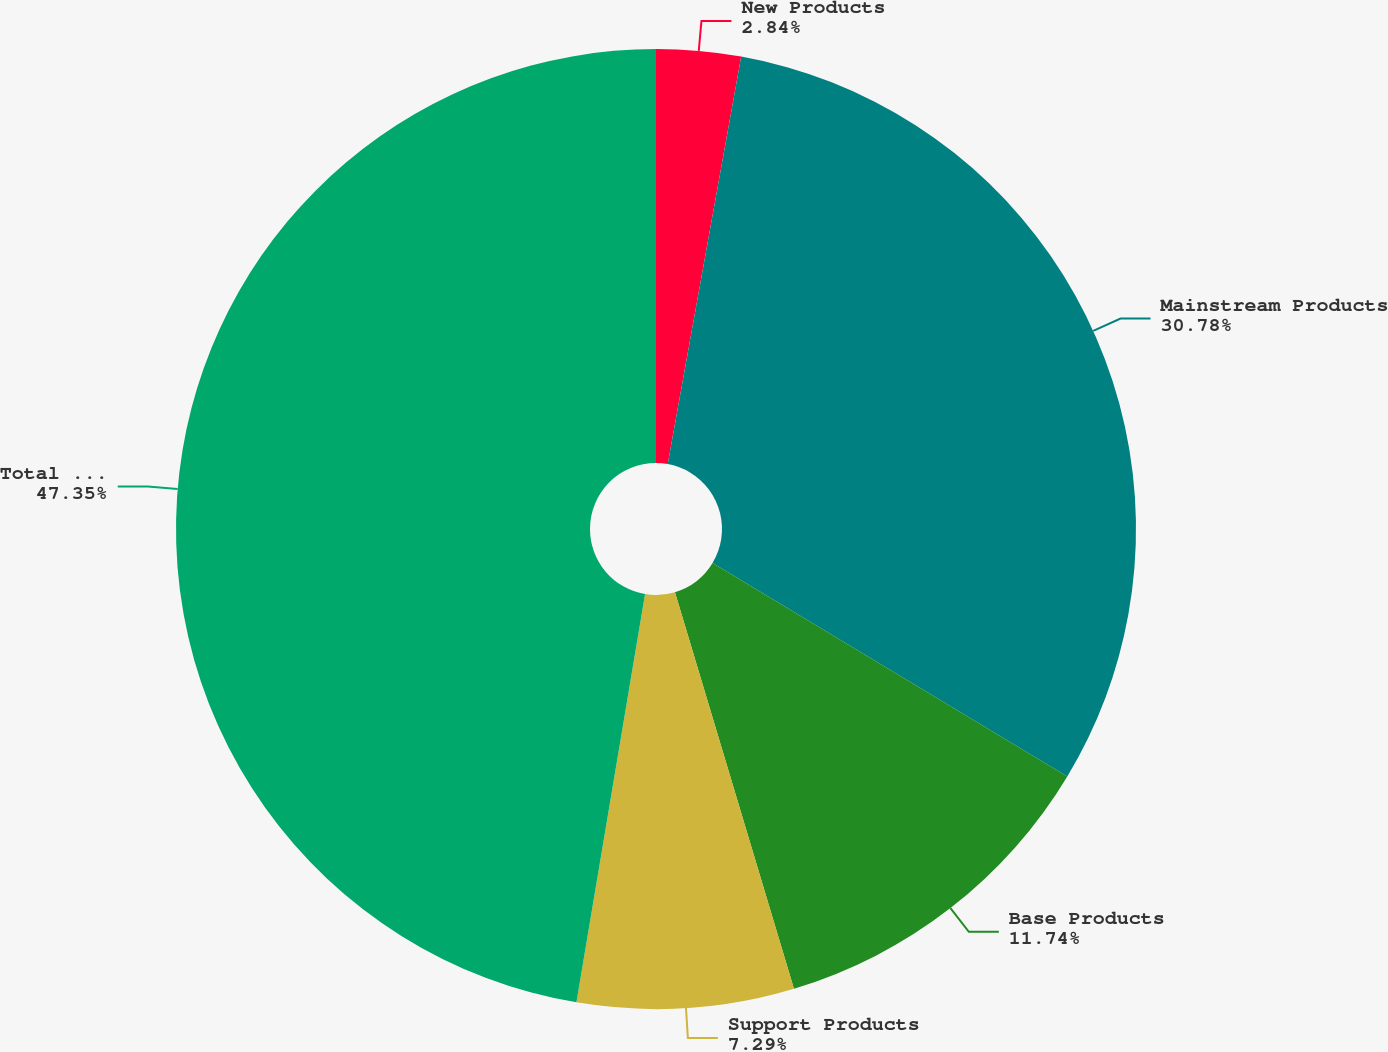<chart> <loc_0><loc_0><loc_500><loc_500><pie_chart><fcel>New Products<fcel>Mainstream Products<fcel>Base Products<fcel>Support Products<fcel>Total Net Revenues<nl><fcel>2.84%<fcel>30.78%<fcel>11.74%<fcel>7.29%<fcel>47.35%<nl></chart> 